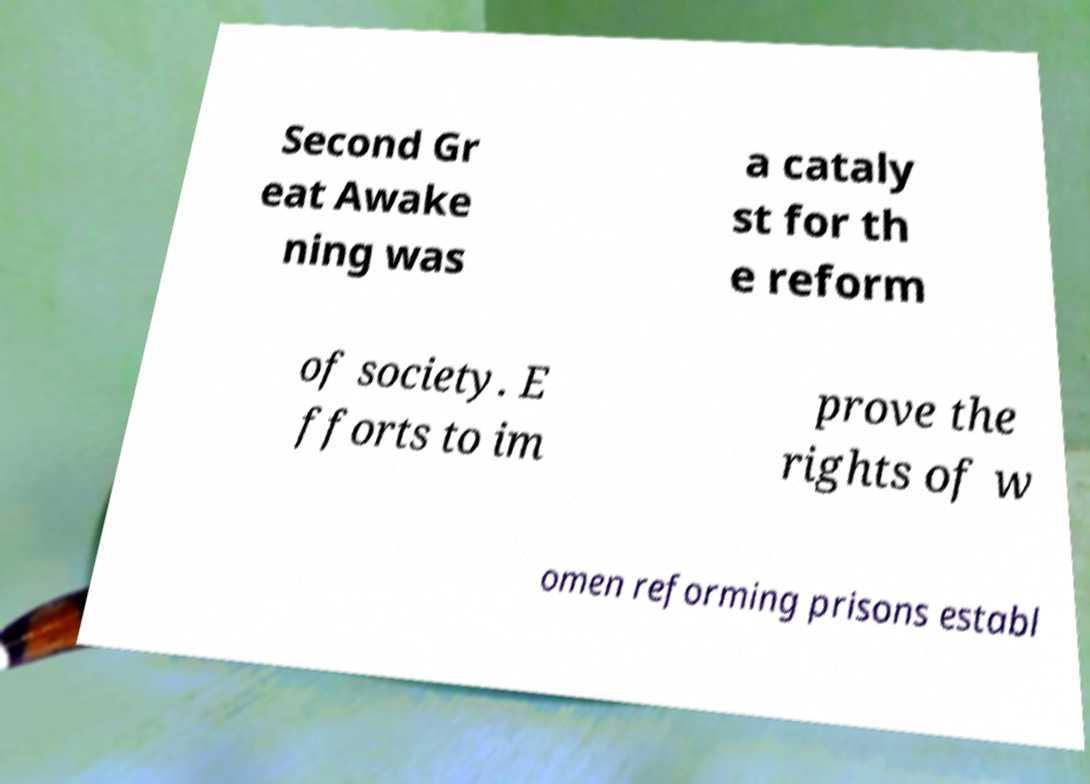Please identify and transcribe the text found in this image. Second Gr eat Awake ning was a cataly st for th e reform of society. E fforts to im prove the rights of w omen reforming prisons establ 